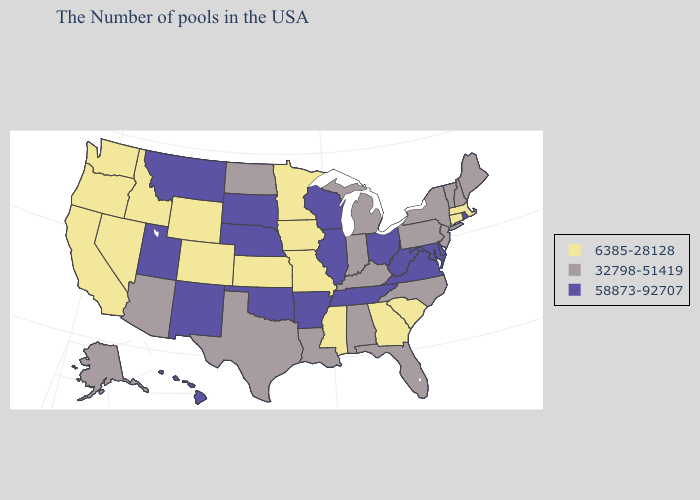What is the value of Arizona?
Quick response, please. 32798-51419. Name the states that have a value in the range 58873-92707?
Short answer required. Rhode Island, Delaware, Maryland, Virginia, West Virginia, Ohio, Tennessee, Wisconsin, Illinois, Arkansas, Nebraska, Oklahoma, South Dakota, New Mexico, Utah, Montana, Hawaii. Does Washington have a lower value than Arizona?
Quick response, please. Yes. What is the highest value in the South ?
Short answer required. 58873-92707. Does Oklahoma have the highest value in the USA?
Give a very brief answer. Yes. Name the states that have a value in the range 32798-51419?
Answer briefly. Maine, New Hampshire, Vermont, New York, New Jersey, Pennsylvania, North Carolina, Florida, Michigan, Kentucky, Indiana, Alabama, Louisiana, Texas, North Dakota, Arizona, Alaska. How many symbols are there in the legend?
Write a very short answer. 3. Among the states that border California , which have the lowest value?
Write a very short answer. Nevada, Oregon. Which states have the lowest value in the South?
Quick response, please. South Carolina, Georgia, Mississippi. Which states have the lowest value in the MidWest?
Be succinct. Missouri, Minnesota, Iowa, Kansas. Name the states that have a value in the range 32798-51419?
Answer briefly. Maine, New Hampshire, Vermont, New York, New Jersey, Pennsylvania, North Carolina, Florida, Michigan, Kentucky, Indiana, Alabama, Louisiana, Texas, North Dakota, Arizona, Alaska. Name the states that have a value in the range 58873-92707?
Be succinct. Rhode Island, Delaware, Maryland, Virginia, West Virginia, Ohio, Tennessee, Wisconsin, Illinois, Arkansas, Nebraska, Oklahoma, South Dakota, New Mexico, Utah, Montana, Hawaii. Which states have the highest value in the USA?
Quick response, please. Rhode Island, Delaware, Maryland, Virginia, West Virginia, Ohio, Tennessee, Wisconsin, Illinois, Arkansas, Nebraska, Oklahoma, South Dakota, New Mexico, Utah, Montana, Hawaii. What is the lowest value in the USA?
Give a very brief answer. 6385-28128. Name the states that have a value in the range 58873-92707?
Be succinct. Rhode Island, Delaware, Maryland, Virginia, West Virginia, Ohio, Tennessee, Wisconsin, Illinois, Arkansas, Nebraska, Oklahoma, South Dakota, New Mexico, Utah, Montana, Hawaii. 